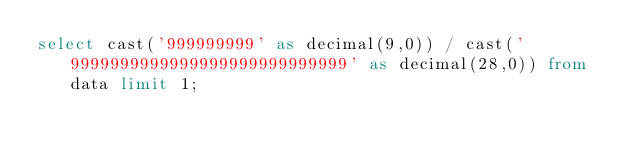Convert code to text. <code><loc_0><loc_0><loc_500><loc_500><_SQL_>select cast('999999999' as decimal(9,0)) / cast('9999999999999999999999999999' as decimal(28,0)) from data limit 1;
</code> 